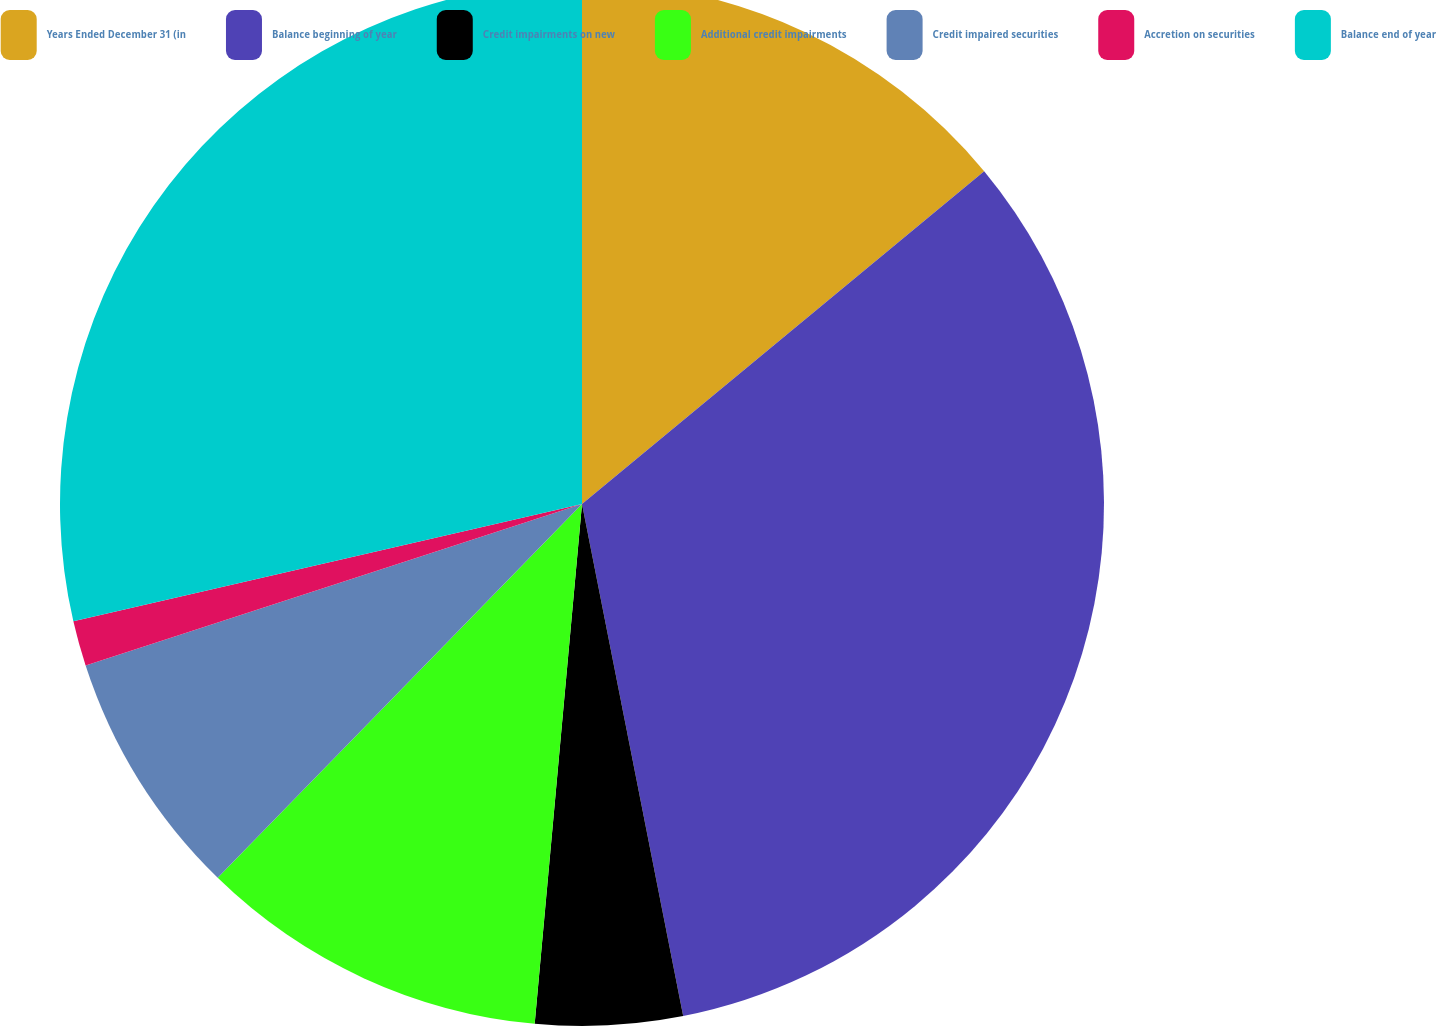Convert chart. <chart><loc_0><loc_0><loc_500><loc_500><pie_chart><fcel>Years Ended December 31 (in<fcel>Balance beginning of year<fcel>Credit impairments on new<fcel>Additional credit impairments<fcel>Credit impaired securities<fcel>Accretion on securities<fcel>Balance end of year<nl><fcel>14.0%<fcel>32.9%<fcel>4.55%<fcel>10.85%<fcel>7.7%<fcel>1.4%<fcel>28.61%<nl></chart> 